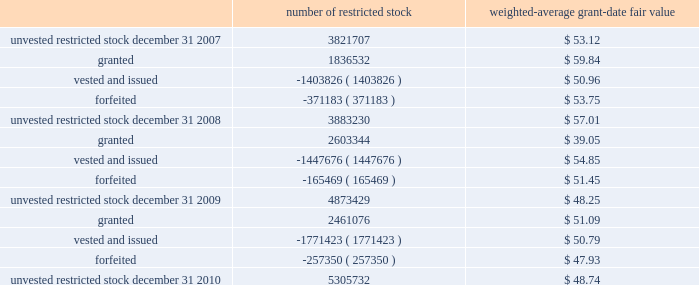N o t e s t o t h e c o n s o l i d a t e d f i n a n c i a l s t a t e m e n t s 2013 ( continued ) ace limited and subsidiaries the weighted-average remaining contractual term was 5.7 years for the stock options outstanding and 4.3 years for the stock options exercisable at december 31 , 2010 .
The total intrinsic value was $ 184 million for stock options outstanding and $ 124 million for stock options exercisable at december 31 , 2010 .
The weighted-average fair value for the stock options granted for the years ended december 31 , 2010 , 2009 , and 2008 , was $ 12.09 , $ 12.95 , and $ 17.60 , respectively .
The total intrinsic value for stock options exercised during the years ended december 31 , 2010 , 2009 , and 2008 , was $ 22 million , $ 12 mil- lion , and $ 54 million , respectively .
The amount of cash received during the year ended december 31 , 2010 , from the exercise of stock options was $ 53 million .
Restricted stock and restricted stock units the company 2019s 2004 ltip provides for grants of restricted stock and restricted stock units with a 4-year vesting period , based on a graded vesting schedule .
The company also grants restricted stock awards to non-management directors which vest at the following year 2019s annual general meeting .
The restricted stock is granted at market close price on the date of grant .
Each restricted stock unit represents the company 2019s obligation to deliver to the holder one common share upon vesting .
Included in the company 2019s share-based compensation expense for the year ended december 31 , 2010 , is a portion of the cost related to the unvested restricted stock granted in the years 2006 2013 2010 .
The table presents a roll-forward of the company 2019s restricted stock for the years ended december 31 , 2010 , 2009 , and 2008 .
Included in the roll-forward below are 36248 and 38154 restricted stock awards that were granted to non-management directors during 2010 and 2009 , respectively .
Number of restricted stock weighted-average grant-date fair .
During 2010 , the company awarded 326091 restricted stock units to officers of the company and its subsidiaries with a weighted-average grant date fair value of $ 50.36 .
During 2009 , 333104 restricted stock units , with a weighted-average grant date fair value of $ 38.75 , were awarded to officers of the company and its subsidiaries .
During 2008 , 223588 restricted stock units , with a weighted-average grant date fair value of $ 59.93 , were awarded to officers of the company and its subsidiaries .
At december 31 , 2010 , the number of unvested restricted stock units was 636758 .
Prior to 2009 , the company granted restricted stock units with a 1-year vesting period to non-management directors .
Delivery of common shares on account of these restricted stock units to non-management directors is deferred until six months after the date of the non-management directors 2019 termination from the board .
During 2008 , 40362 restricted stock units were awarded to non-management directors .
At december 31 , 2010 , the number of deferred restricted stock units was 230451 .
The espp gives participating employees the right to purchase common shares through payroll deductions during consecutive 201csubscription periods 201d at a purchase price of 85 percent of the fair value of a common share on the exercise date .
Annual purchases by participants are limited to the number of whole shares that can be purchased by an amount equal to ten percent .
What is the net change in the number of unvested restricted stock in 2008? 
Computations: (3883230 - 3821707)
Answer: 61523.0. 